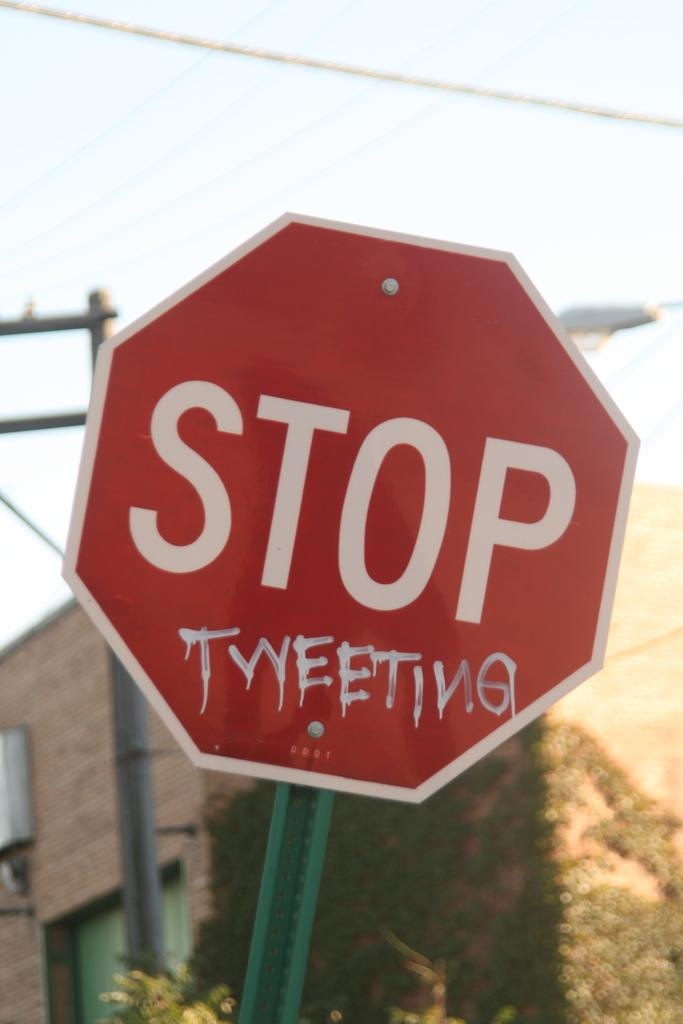<image>
Summarize the visual content of the image. A red STOP sign has the phrase "tweeting" sprawled right below it. 